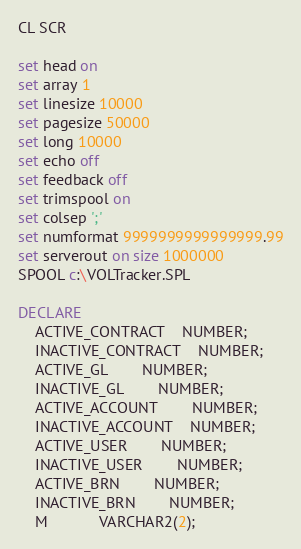Convert code to text. <code><loc_0><loc_0><loc_500><loc_500><_SQL_>CL SCR

set head on
set array 1
set linesize 10000
set pagesize 50000
set long 10000
set echo off
set feedback off
set trimspool on
set colsep ';'
set numformat 9999999999999999.99
set serverout on size 1000000
SPOOL c:\VOLTracker.SPL

DECLARE
	ACTIVE_CONTRACT 	NUMBER;
	INACTIVE_CONTRACT 	NUMBER;
	ACTIVE_GL 		NUMBER;
	INACTIVE_GL 		NUMBER;
	ACTIVE_ACCOUNT 		NUMBER;
	INACTIVE_ACCOUNT 	NUMBER;
	ACTIVE_USER 		NUMBER;
	INACTIVE_USER 		NUMBER;
	ACTIVE_BRN 		NUMBER;
	INACTIVE_BRN 		NUMBER;
	M 			VARCHAR2(2);</code> 